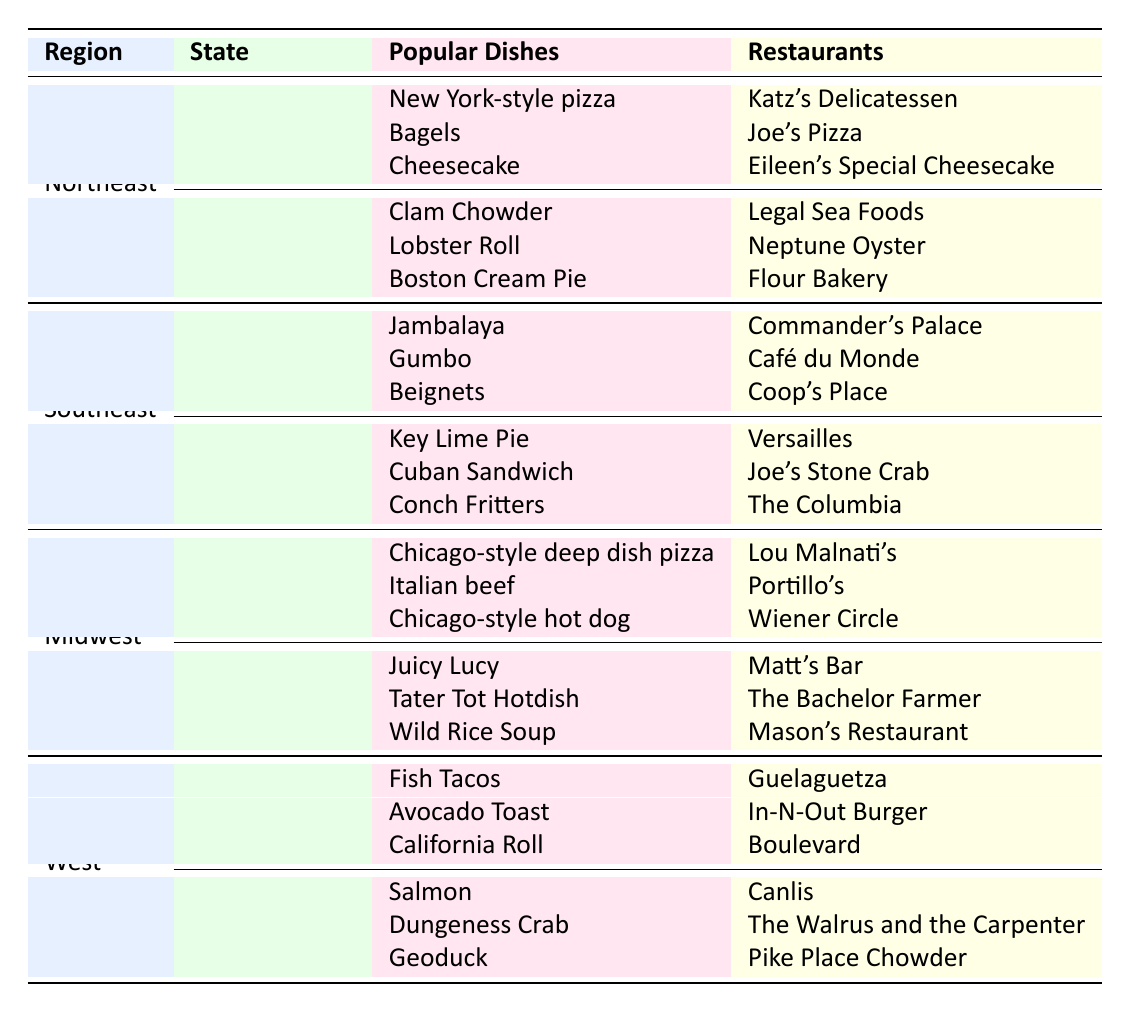What are the popular dishes in Florida? The table lists the popular dishes under the Southeast region and specifies Florida's popular dishes. These include Key Lime Pie, Cuban Sandwich, and Conch Fritters.
Answer: Key Lime Pie, Cuban Sandwich, Conch Fritters Which state has the most popular dishes listed in the table? By counting the number of popular dishes for each state, New York, Massachusetts, Louisiana, Florida, Illinois, Minnesota, California, and Washington each have three popular dishes listed. As all states are equal in this case, no single state has more.
Answer: None; all have three Is Jambalaya a popular dish in the Midwest? By checking the Midwest section, Jambalaya is listed under Louisiana in the Southeast region, and there is no mention of it in the Midwest section.
Answer: No Which restaurant is famous for serving Clam Chowder? The table specifies the restaurant associated with each popular dish, and Clam Chowder is served at Legal Sea Foods in Massachusetts.
Answer: Legal Sea Foods What is the total number of popular dishes listed for all states in the table? Each state has three popular dishes, with a total of eight states. Therefore, the total number is calculated as 8 states multiplied by 3 dishes per state, which equals 24.
Answer: 24 What can you say about the regional distribution of seafood dishes in the table? Seafood dishes are highlighted in multiple states: Clam Chowder (Massachusetts), Jambalaya (Louisiana), Salmon (Washington), and Dungeness Crab (Washington). This shows that seafood is popular in both the Northeast and Southeast, as well as the West regions.
Answer: Contains popular seafood dishes in Northeast, Southeast, and West regions 